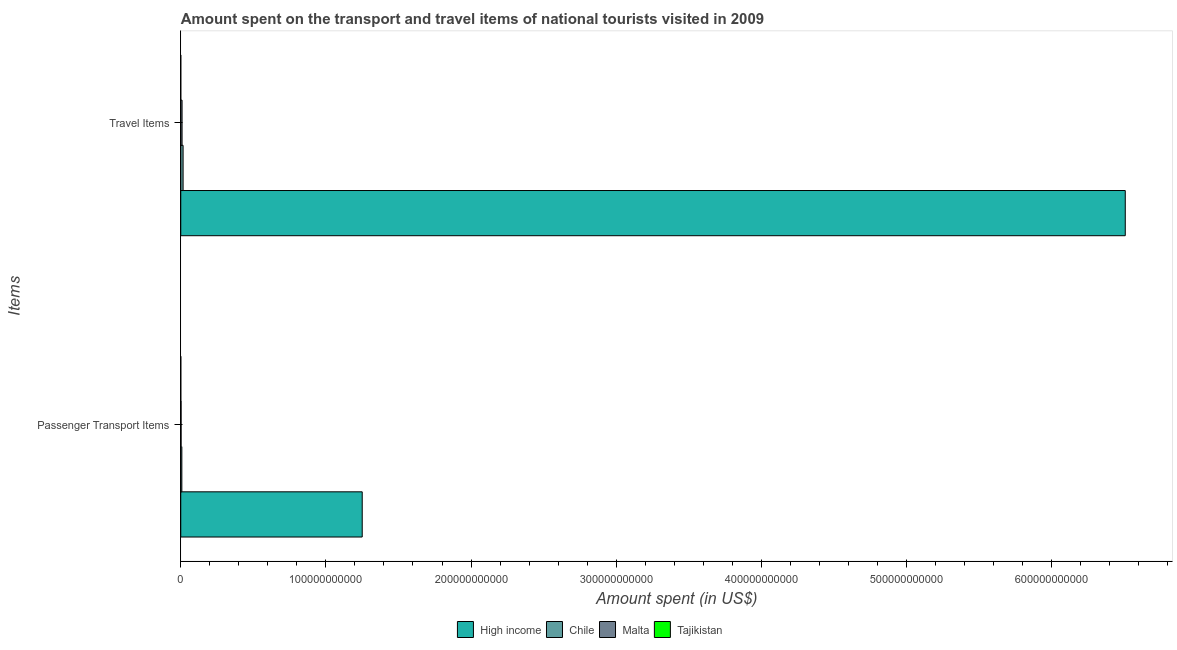How many groups of bars are there?
Provide a short and direct response. 2. Are the number of bars per tick equal to the number of legend labels?
Give a very brief answer. Yes. How many bars are there on the 1st tick from the top?
Provide a succinct answer. 4. What is the label of the 2nd group of bars from the top?
Provide a short and direct response. Passenger Transport Items. What is the amount spent on passenger transport items in High income?
Provide a succinct answer. 1.25e+11. Across all countries, what is the maximum amount spent in travel items?
Your answer should be compact. 6.51e+11. Across all countries, what is the minimum amount spent on passenger transport items?
Provide a short and direct response. 1.71e+07. In which country was the amount spent on passenger transport items minimum?
Ensure brevity in your answer.  Tajikistan. What is the total amount spent on passenger transport items in the graph?
Provide a short and direct response. 1.26e+11. What is the difference between the amount spent in travel items in Chile and that in Tajikistan?
Your response must be concise. 1.60e+09. What is the difference between the amount spent in travel items in Chile and the amount spent on passenger transport items in Tajikistan?
Ensure brevity in your answer.  1.59e+09. What is the average amount spent on passenger transport items per country?
Make the answer very short. 3.15e+1. What is the difference between the amount spent on passenger transport items and amount spent in travel items in High income?
Your answer should be compact. -5.26e+11. What is the ratio of the amount spent on passenger transport items in Chile to that in Malta?
Ensure brevity in your answer.  3.42. In how many countries, is the amount spent in travel items greater than the average amount spent in travel items taken over all countries?
Your response must be concise. 1. What does the 2nd bar from the top in Travel Items represents?
Provide a succinct answer. Malta. What does the 3rd bar from the bottom in Travel Items represents?
Give a very brief answer. Malta. Are all the bars in the graph horizontal?
Your answer should be very brief. Yes. What is the difference between two consecutive major ticks on the X-axis?
Keep it short and to the point. 1.00e+11. How many legend labels are there?
Give a very brief answer. 4. What is the title of the graph?
Provide a short and direct response. Amount spent on the transport and travel items of national tourists visited in 2009. Does "Argentina" appear as one of the legend labels in the graph?
Your response must be concise. No. What is the label or title of the X-axis?
Offer a very short reply. Amount spent (in US$). What is the label or title of the Y-axis?
Keep it short and to the point. Items. What is the Amount spent (in US$) of High income in Passenger Transport Items?
Ensure brevity in your answer.  1.25e+11. What is the Amount spent (in US$) of Chile in Passenger Transport Items?
Offer a very short reply. 7.46e+08. What is the Amount spent (in US$) in Malta in Passenger Transport Items?
Provide a succinct answer. 2.18e+08. What is the Amount spent (in US$) of Tajikistan in Passenger Transport Items?
Your response must be concise. 1.71e+07. What is the Amount spent (in US$) in High income in Travel Items?
Your response must be concise. 6.51e+11. What is the Amount spent (in US$) in Chile in Travel Items?
Keep it short and to the point. 1.60e+09. What is the Amount spent (in US$) of Malta in Travel Items?
Ensure brevity in your answer.  8.99e+08. What is the Amount spent (in US$) in Tajikistan in Travel Items?
Keep it short and to the point. 2.40e+06. Across all Items, what is the maximum Amount spent (in US$) in High income?
Offer a terse response. 6.51e+11. Across all Items, what is the maximum Amount spent (in US$) in Chile?
Provide a short and direct response. 1.60e+09. Across all Items, what is the maximum Amount spent (in US$) in Malta?
Provide a short and direct response. 8.99e+08. Across all Items, what is the maximum Amount spent (in US$) in Tajikistan?
Provide a short and direct response. 1.71e+07. Across all Items, what is the minimum Amount spent (in US$) in High income?
Your answer should be very brief. 1.25e+11. Across all Items, what is the minimum Amount spent (in US$) of Chile?
Your answer should be very brief. 7.46e+08. Across all Items, what is the minimum Amount spent (in US$) in Malta?
Offer a very short reply. 2.18e+08. Across all Items, what is the minimum Amount spent (in US$) in Tajikistan?
Your answer should be compact. 2.40e+06. What is the total Amount spent (in US$) in High income in the graph?
Give a very brief answer. 7.76e+11. What is the total Amount spent (in US$) in Chile in the graph?
Offer a terse response. 2.35e+09. What is the total Amount spent (in US$) of Malta in the graph?
Make the answer very short. 1.12e+09. What is the total Amount spent (in US$) in Tajikistan in the graph?
Give a very brief answer. 1.95e+07. What is the difference between the Amount spent (in US$) of High income in Passenger Transport Items and that in Travel Items?
Offer a very short reply. -5.26e+11. What is the difference between the Amount spent (in US$) in Chile in Passenger Transport Items and that in Travel Items?
Make the answer very short. -8.58e+08. What is the difference between the Amount spent (in US$) of Malta in Passenger Transport Items and that in Travel Items?
Give a very brief answer. -6.81e+08. What is the difference between the Amount spent (in US$) of Tajikistan in Passenger Transport Items and that in Travel Items?
Provide a succinct answer. 1.47e+07. What is the difference between the Amount spent (in US$) of High income in Passenger Transport Items and the Amount spent (in US$) of Chile in Travel Items?
Offer a very short reply. 1.23e+11. What is the difference between the Amount spent (in US$) of High income in Passenger Transport Items and the Amount spent (in US$) of Malta in Travel Items?
Make the answer very short. 1.24e+11. What is the difference between the Amount spent (in US$) in High income in Passenger Transport Items and the Amount spent (in US$) in Tajikistan in Travel Items?
Provide a succinct answer. 1.25e+11. What is the difference between the Amount spent (in US$) in Chile in Passenger Transport Items and the Amount spent (in US$) in Malta in Travel Items?
Ensure brevity in your answer.  -1.53e+08. What is the difference between the Amount spent (in US$) of Chile in Passenger Transport Items and the Amount spent (in US$) of Tajikistan in Travel Items?
Ensure brevity in your answer.  7.44e+08. What is the difference between the Amount spent (in US$) in Malta in Passenger Transport Items and the Amount spent (in US$) in Tajikistan in Travel Items?
Your answer should be compact. 2.16e+08. What is the average Amount spent (in US$) of High income per Items?
Make the answer very short. 3.88e+11. What is the average Amount spent (in US$) of Chile per Items?
Provide a succinct answer. 1.18e+09. What is the average Amount spent (in US$) of Malta per Items?
Ensure brevity in your answer.  5.58e+08. What is the average Amount spent (in US$) of Tajikistan per Items?
Keep it short and to the point. 9.75e+06. What is the difference between the Amount spent (in US$) of High income and Amount spent (in US$) of Chile in Passenger Transport Items?
Your answer should be compact. 1.24e+11. What is the difference between the Amount spent (in US$) of High income and Amount spent (in US$) of Malta in Passenger Transport Items?
Your answer should be very brief. 1.25e+11. What is the difference between the Amount spent (in US$) in High income and Amount spent (in US$) in Tajikistan in Passenger Transport Items?
Make the answer very short. 1.25e+11. What is the difference between the Amount spent (in US$) of Chile and Amount spent (in US$) of Malta in Passenger Transport Items?
Ensure brevity in your answer.  5.28e+08. What is the difference between the Amount spent (in US$) in Chile and Amount spent (in US$) in Tajikistan in Passenger Transport Items?
Ensure brevity in your answer.  7.29e+08. What is the difference between the Amount spent (in US$) of Malta and Amount spent (in US$) of Tajikistan in Passenger Transport Items?
Offer a terse response. 2.01e+08. What is the difference between the Amount spent (in US$) in High income and Amount spent (in US$) in Chile in Travel Items?
Keep it short and to the point. 6.49e+11. What is the difference between the Amount spent (in US$) in High income and Amount spent (in US$) in Malta in Travel Items?
Your answer should be compact. 6.50e+11. What is the difference between the Amount spent (in US$) of High income and Amount spent (in US$) of Tajikistan in Travel Items?
Offer a terse response. 6.51e+11. What is the difference between the Amount spent (in US$) of Chile and Amount spent (in US$) of Malta in Travel Items?
Make the answer very short. 7.05e+08. What is the difference between the Amount spent (in US$) of Chile and Amount spent (in US$) of Tajikistan in Travel Items?
Offer a very short reply. 1.60e+09. What is the difference between the Amount spent (in US$) of Malta and Amount spent (in US$) of Tajikistan in Travel Items?
Your answer should be compact. 8.97e+08. What is the ratio of the Amount spent (in US$) in High income in Passenger Transport Items to that in Travel Items?
Give a very brief answer. 0.19. What is the ratio of the Amount spent (in US$) of Chile in Passenger Transport Items to that in Travel Items?
Provide a succinct answer. 0.47. What is the ratio of the Amount spent (in US$) of Malta in Passenger Transport Items to that in Travel Items?
Your response must be concise. 0.24. What is the ratio of the Amount spent (in US$) in Tajikistan in Passenger Transport Items to that in Travel Items?
Provide a succinct answer. 7.12. What is the difference between the highest and the second highest Amount spent (in US$) in High income?
Provide a succinct answer. 5.26e+11. What is the difference between the highest and the second highest Amount spent (in US$) of Chile?
Your response must be concise. 8.58e+08. What is the difference between the highest and the second highest Amount spent (in US$) in Malta?
Make the answer very short. 6.81e+08. What is the difference between the highest and the second highest Amount spent (in US$) of Tajikistan?
Your answer should be very brief. 1.47e+07. What is the difference between the highest and the lowest Amount spent (in US$) of High income?
Your response must be concise. 5.26e+11. What is the difference between the highest and the lowest Amount spent (in US$) of Chile?
Give a very brief answer. 8.58e+08. What is the difference between the highest and the lowest Amount spent (in US$) of Malta?
Your response must be concise. 6.81e+08. What is the difference between the highest and the lowest Amount spent (in US$) in Tajikistan?
Provide a succinct answer. 1.47e+07. 